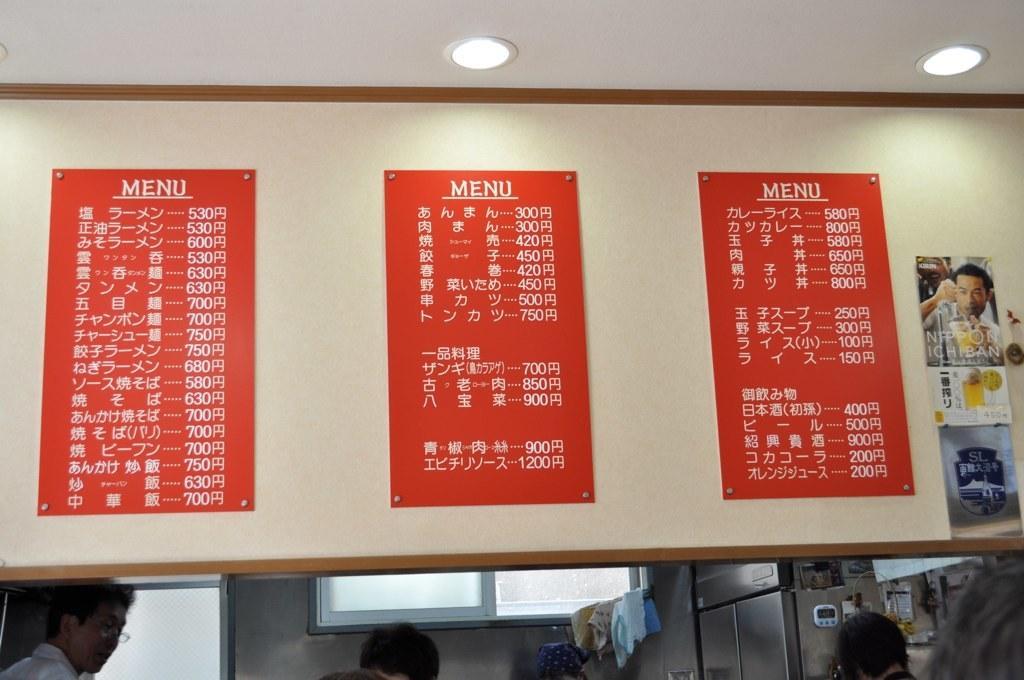Describe this image in one or two sentences. At the bottom of the image there are heads of few people. And also there are machines. On the wall there are glass windows and also there is a door. At the top of the image there are lights and also there are boards with text on it. And also there are posters. 